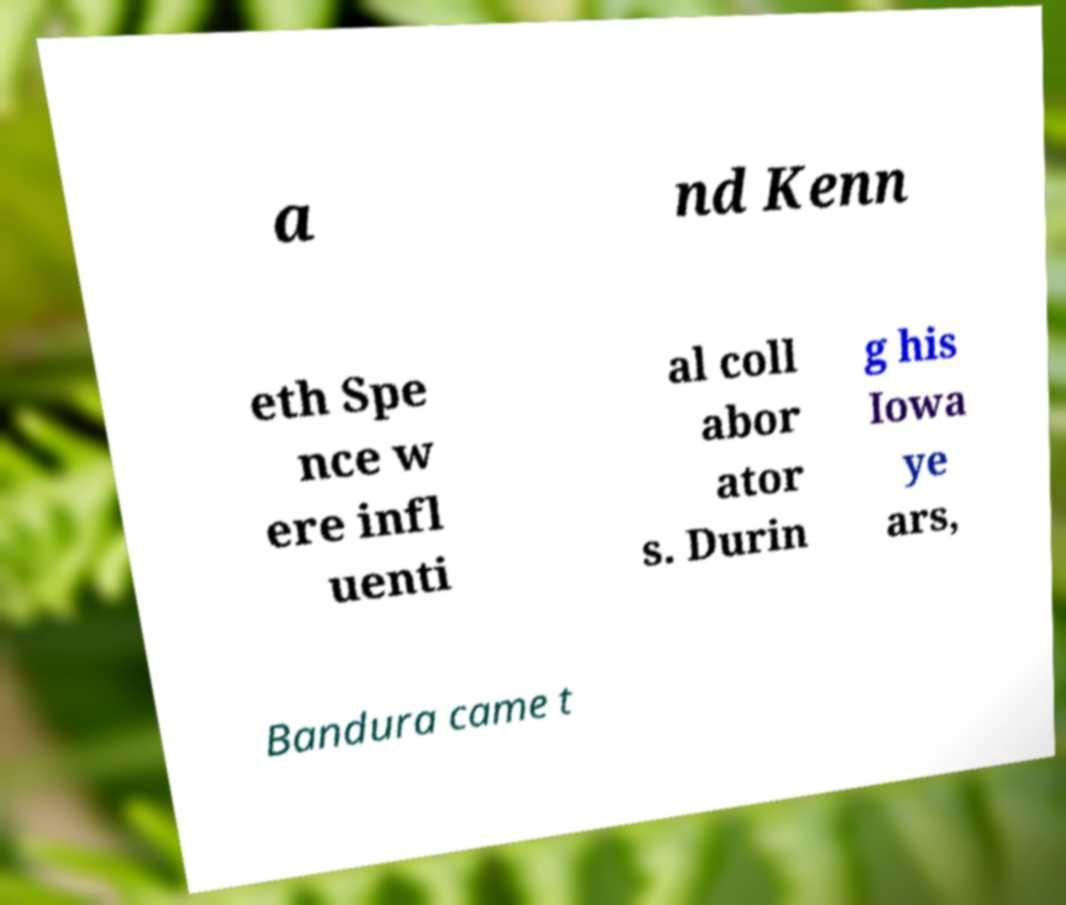What messages or text are displayed in this image? I need them in a readable, typed format. a nd Kenn eth Spe nce w ere infl uenti al coll abor ator s. Durin g his Iowa ye ars, Bandura came t 